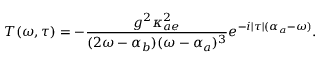Convert formula to latex. <formula><loc_0><loc_0><loc_500><loc_500>T ( \omega , \tau ) = - \frac { g ^ { 2 } \kappa _ { a e } ^ { 2 } } { ( 2 \omega - \alpha _ { b } ) ( \omega - \alpha _ { a } ) ^ { 3 } } e ^ { - i | \tau | ( \alpha _ { a } - \omega ) } .</formula> 